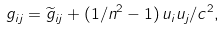<formula> <loc_0><loc_0><loc_500><loc_500>g _ { i j } = \widetilde { g } _ { i j } + ( 1 / n ^ { 2 } - 1 ) \, u _ { i } u _ { j } / c ^ { 2 } ,</formula> 